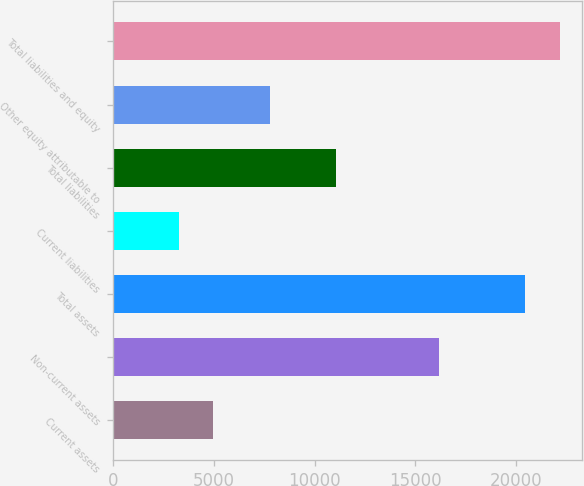<chart> <loc_0><loc_0><loc_500><loc_500><bar_chart><fcel>Current assets<fcel>Non-current assets<fcel>Total assets<fcel>Current liabilities<fcel>Total liabilities<fcel>Other equity attributable to<fcel>Total liabilities and equity<nl><fcel>4982.46<fcel>16169.6<fcel>20444.1<fcel>3264.5<fcel>11083.2<fcel>7769.1<fcel>22162.1<nl></chart> 